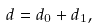<formula> <loc_0><loc_0><loc_500><loc_500>d = d _ { 0 } + d _ { 1 } ,</formula> 